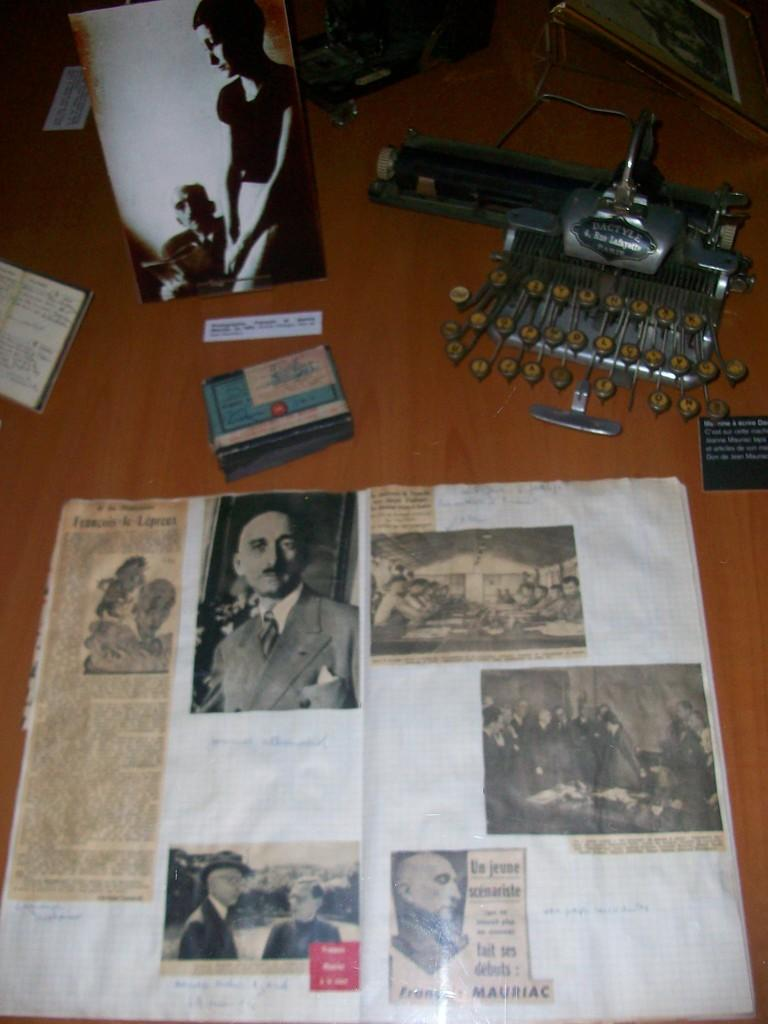What type of object can be seen in the image? There is a book in the image. What else is present in the image besides the book? There are posters, pictures of persons, cards, a photo, and a machine in the image. What is the common theme among these objects? They all seem to be related to visual media or communication. Where are these objects located? The objects are on a wooden platform. What type of religious event is taking place in the image? There is no indication of a religious event in the image; it features various objects related to visual media or communication on a wooden platform. 